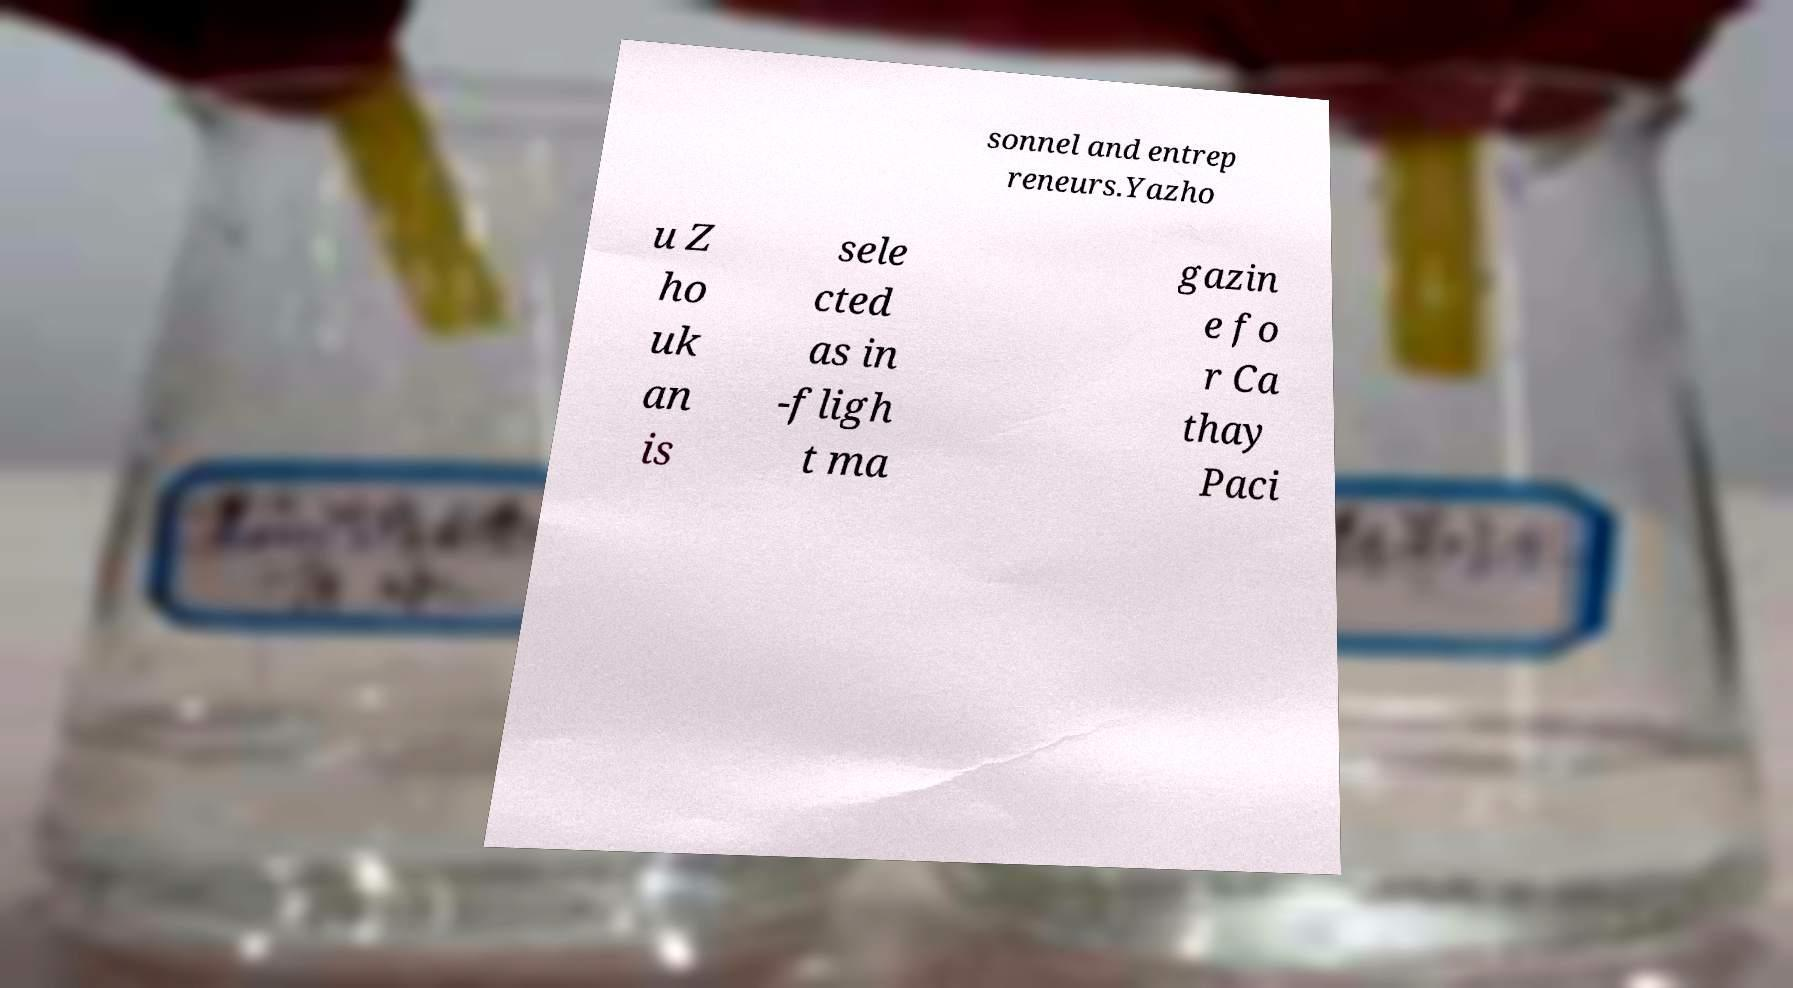Could you extract and type out the text from this image? sonnel and entrep reneurs.Yazho u Z ho uk an is sele cted as in -fligh t ma gazin e fo r Ca thay Paci 